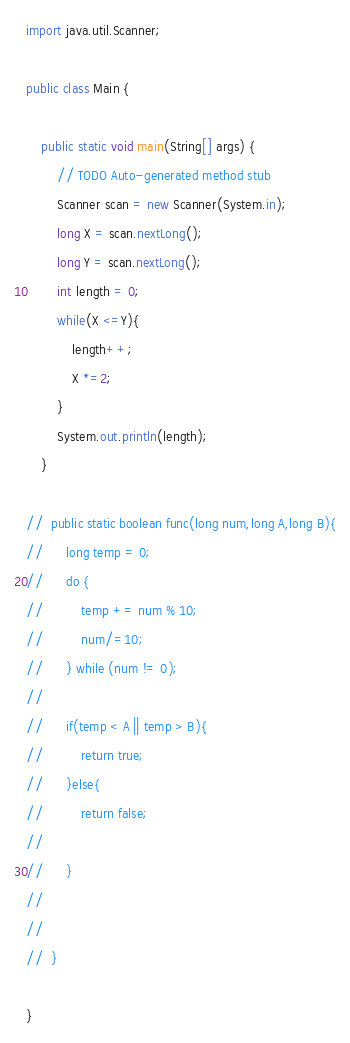<code> <loc_0><loc_0><loc_500><loc_500><_Java_>import java.util.Scanner;
 
public class Main {
 
	public static void main(String[] args) {
		// TODO Auto-generated method stub
		Scanner scan = new Scanner(System.in);
		long X = scan.nextLong();
		long Y = scan.nextLong();
		int length = 0;
		while(X <=Y){
			length++;
			X *=2;
		}
		System.out.println(length);
	}
	
//	public static boolean func(long num,long A,long B){
//		long temp = 0;
//		do {
//			temp += num % 10;
//			num/=10;
//		} while (num != 0);
//		
//		if(temp < A || temp > B){
//			return true;
//		}else{
//			return false;
//			
//		}
//		
//		
//	}
 
}</code> 